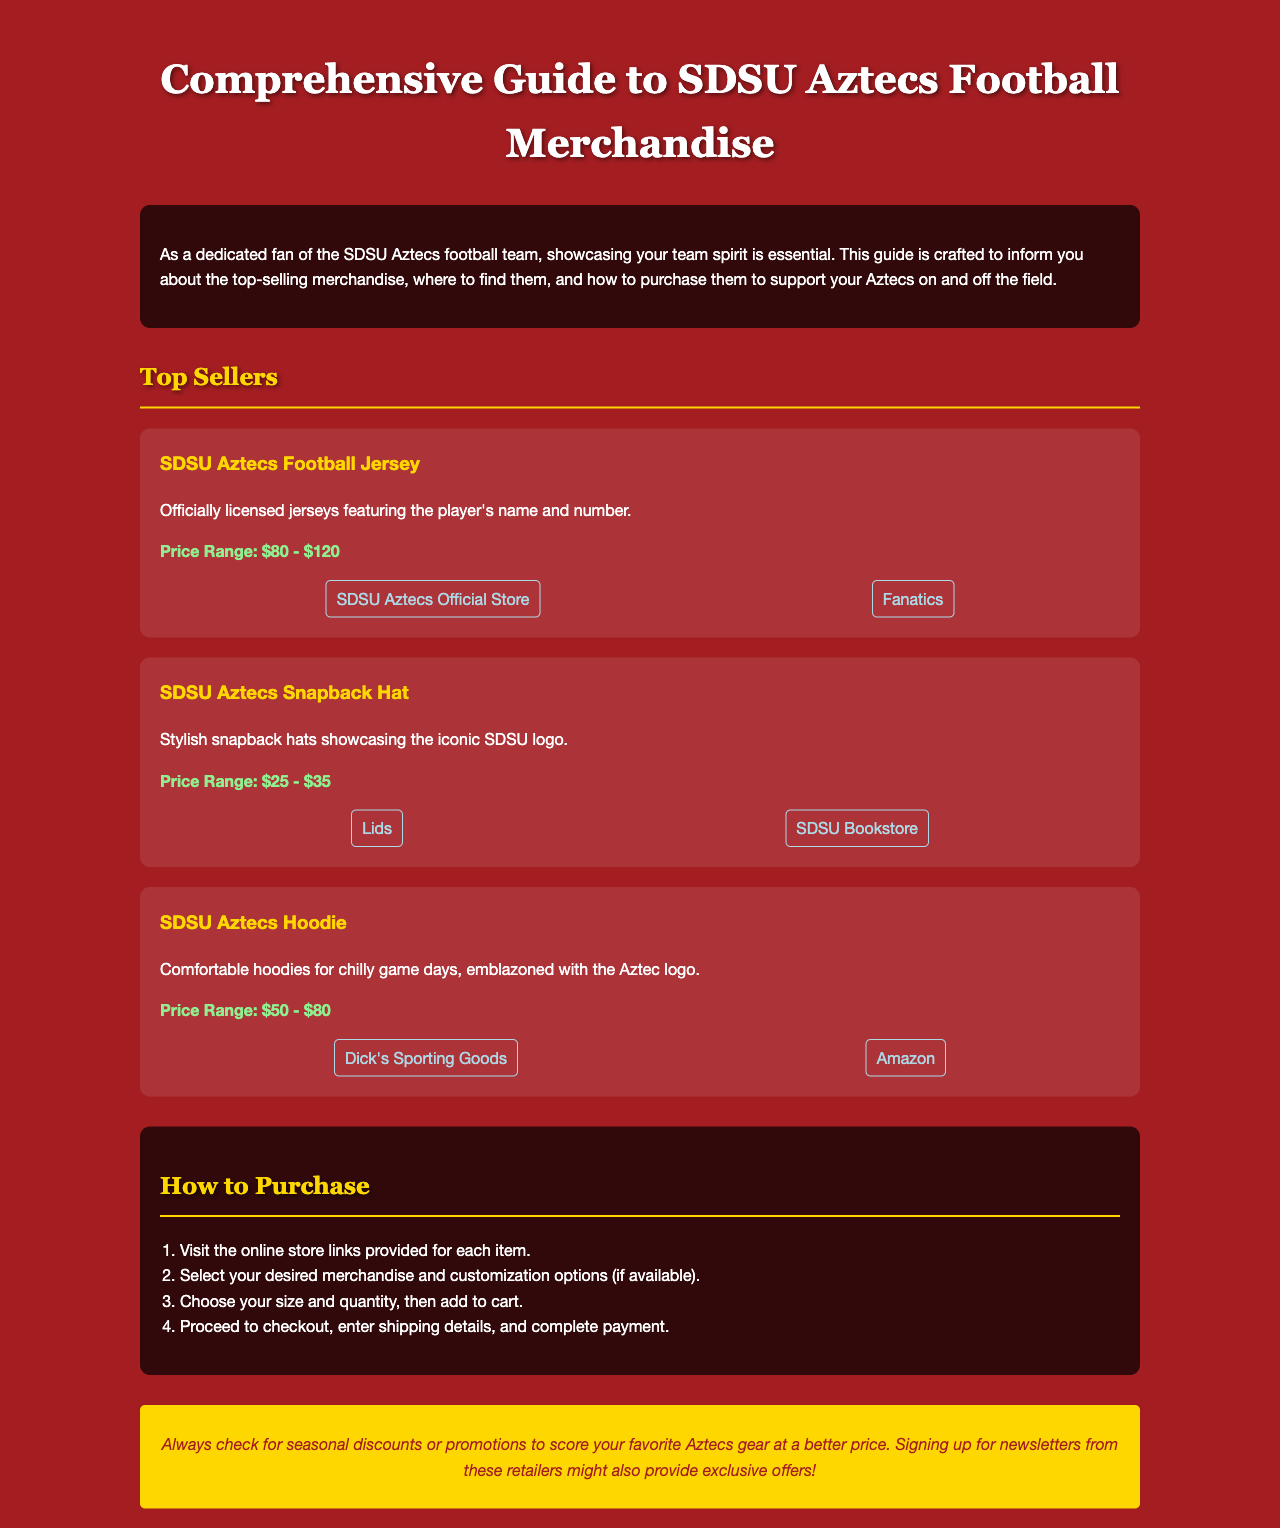What is the price range for SDSU Aztecs Football Jerseys? The price range for SDSU Aztecs Football Jerseys is mentioned in the document.
Answer: $80 - $120 Where can you buy the SDSU Aztecs Snapback Hat? The document lists two places to purchase the snapback hat.
Answer: Lids, SDSU Bookstore How much does the SDSU Aztecs Hoodie cost? The price range for the SDSU Aztecs Hoodie is specified in the document.
Answer: $50 - $80 What is the first step in the purchasing process? The document outlines several steps for purchasing merchandise.
Answer: Visit the online store links Which item features the player's name and number? The document describes various merchandise items, specifying one that includes player information.
Answer: SDSU Aztecs Football Jersey What suggestion is given for finding discounts? The document provides a tip for obtaining merchandise at better prices.
Answer: Check for seasonal discounts 